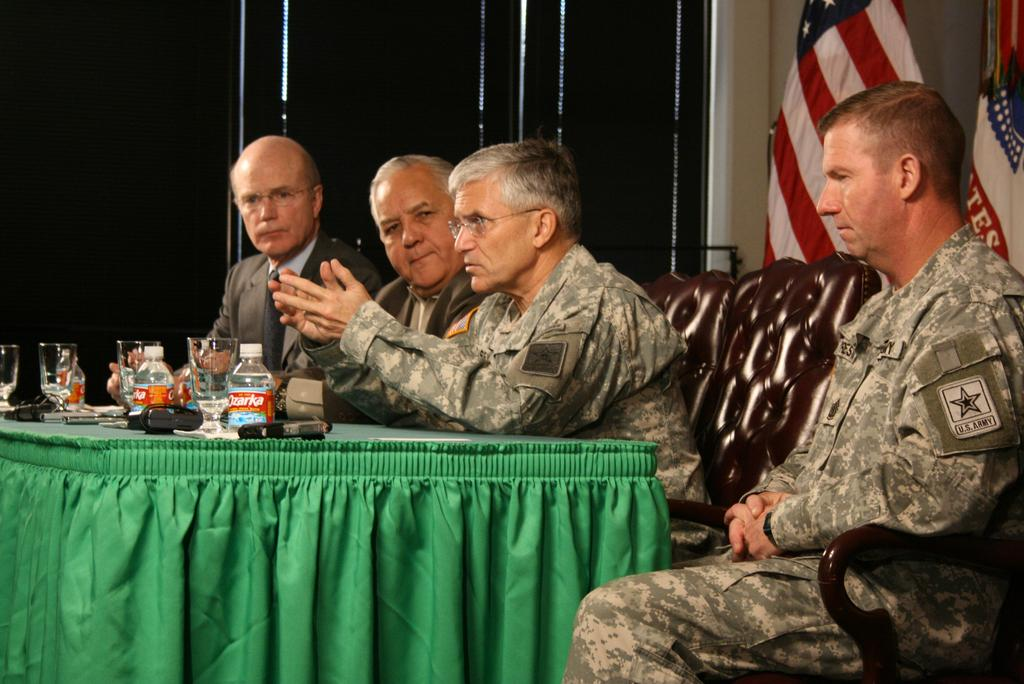What are the people in the image doing? The people in the image are sitting on chairs. What is the main piece of furniture in the image? There is a table in the image. What can be found on the table? Bottles, glasses, and other objects are present on the table. Where are the flags located in the image? The flags are on the right side of the image. What type of bird can be seen flying at night in the image? There is no bird or nighttime setting present in the image. Is there a kettle visible on the table in the image? There is no kettle mentioned or visible in the image. 